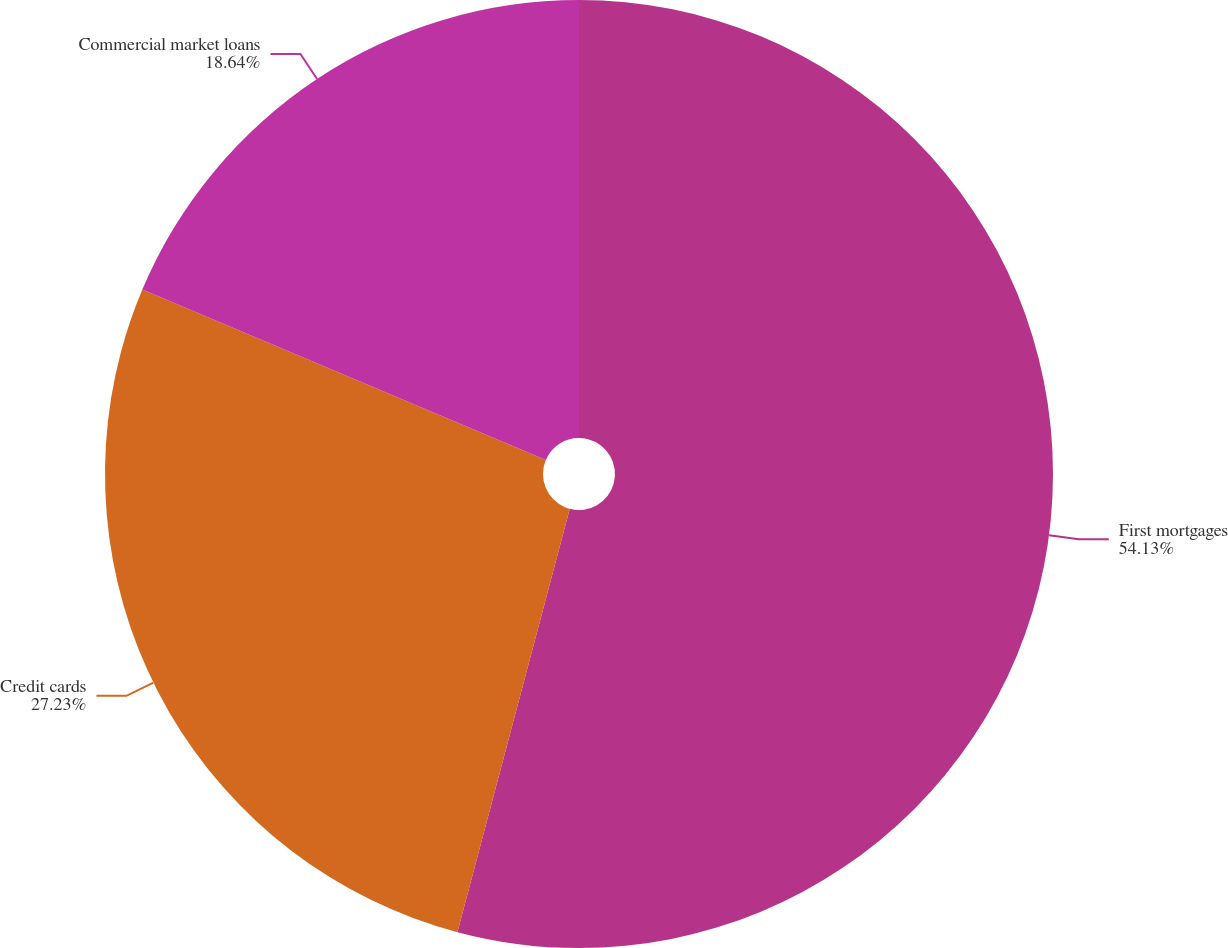Convert chart to OTSL. <chart><loc_0><loc_0><loc_500><loc_500><pie_chart><fcel>First mortgages<fcel>Credit cards<fcel>Commercial market loans<nl><fcel>54.13%<fcel>27.23%<fcel>18.64%<nl></chart> 